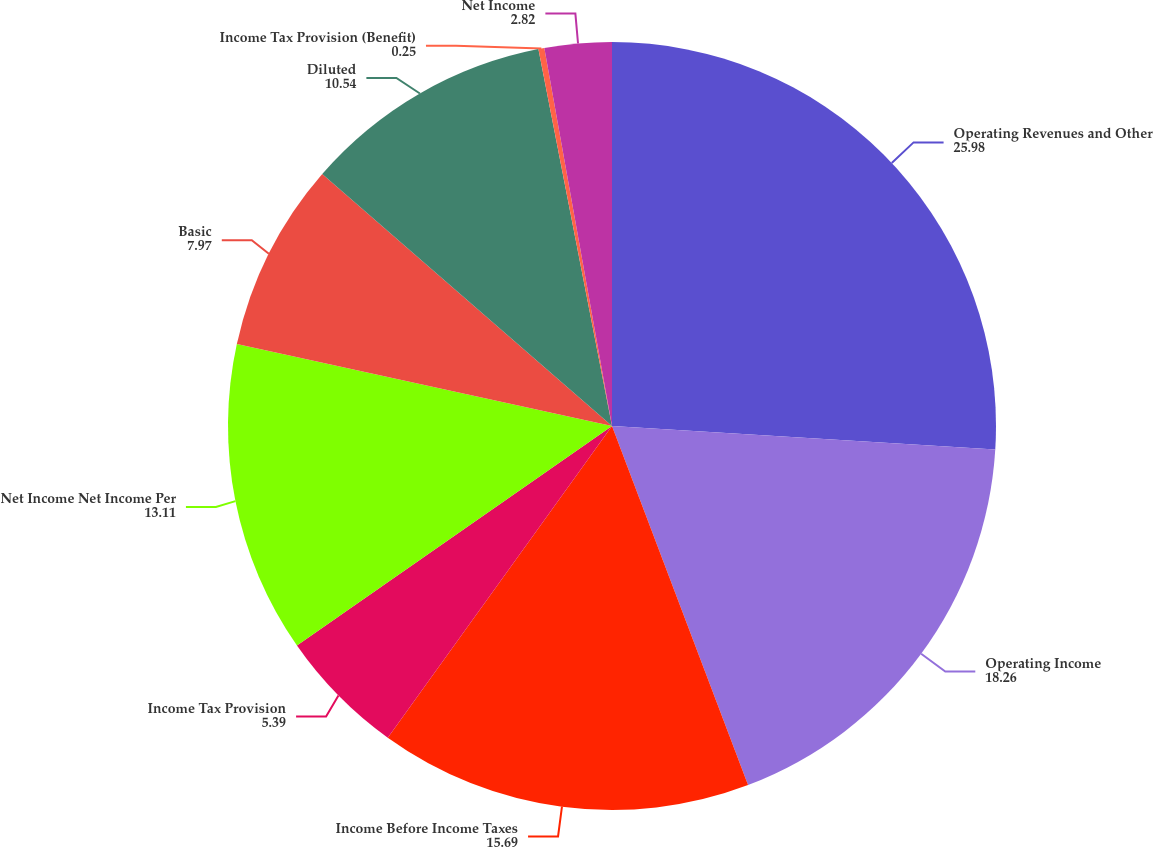<chart> <loc_0><loc_0><loc_500><loc_500><pie_chart><fcel>Operating Revenues and Other<fcel>Operating Income<fcel>Income Before Income Taxes<fcel>Income Tax Provision<fcel>Net Income Net Income Per<fcel>Basic<fcel>Diluted<fcel>Income Tax Provision (Benefit)<fcel>Net Income<nl><fcel>25.98%<fcel>18.26%<fcel>15.69%<fcel>5.39%<fcel>13.11%<fcel>7.97%<fcel>10.54%<fcel>0.25%<fcel>2.82%<nl></chart> 